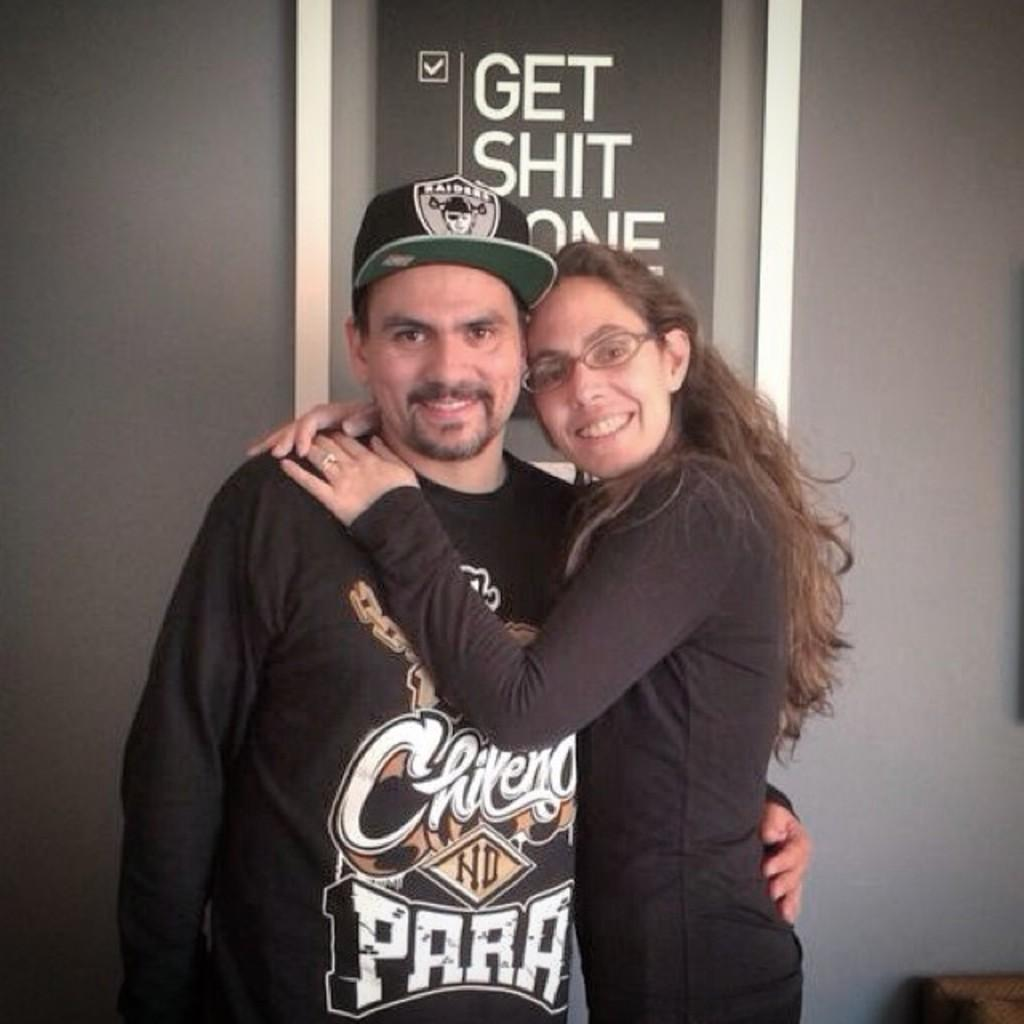<image>
Summarize the visual content of the image. A man in a shirt with the word PARA on it is being hugged by a woman. 